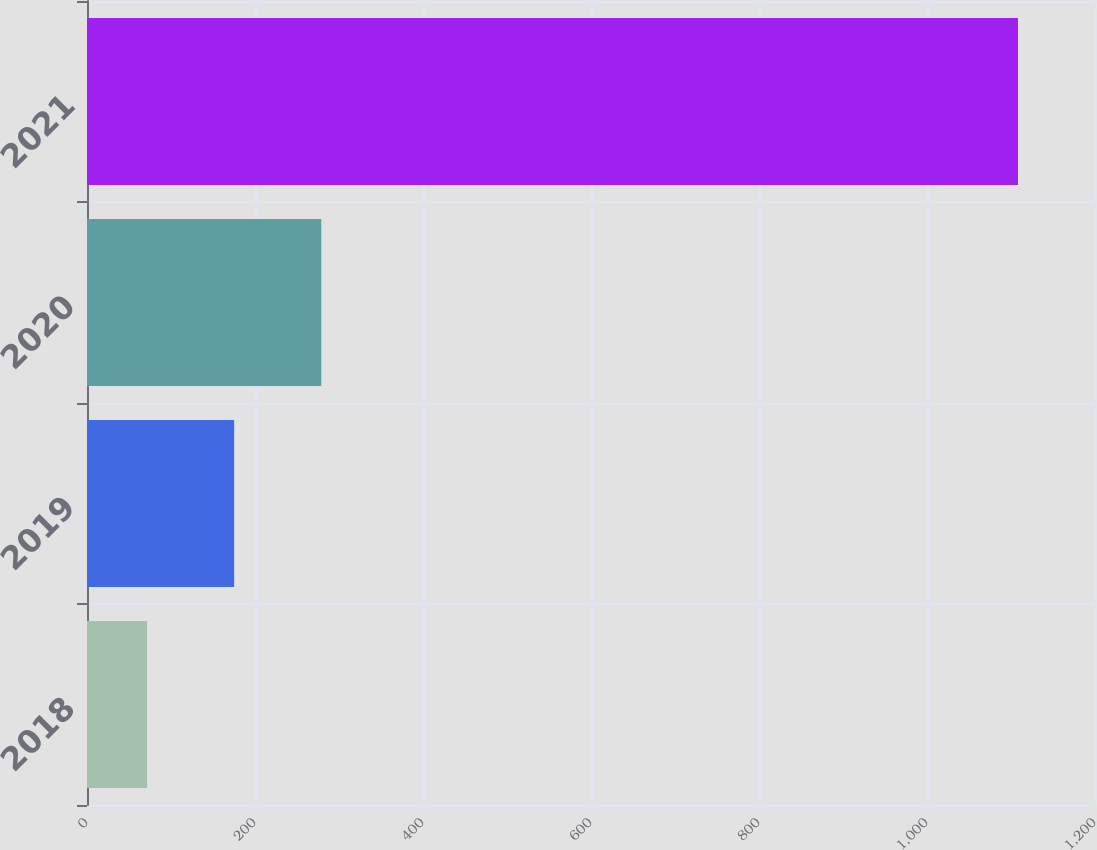<chart> <loc_0><loc_0><loc_500><loc_500><bar_chart><fcel>2018<fcel>2019<fcel>2020<fcel>2021<nl><fcel>71.5<fcel>175.18<fcel>278.86<fcel>1108.3<nl></chart> 